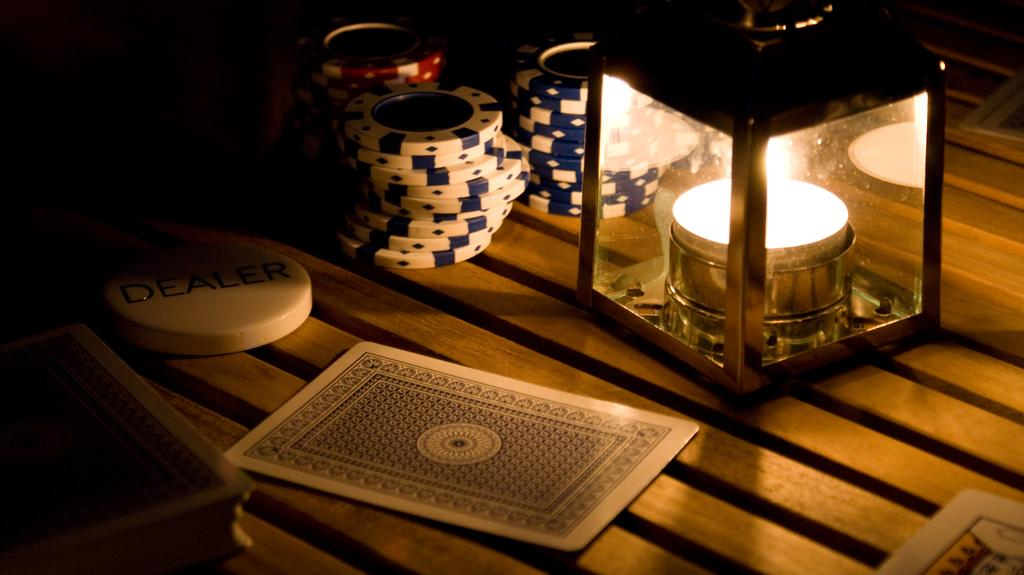What is the main object in the center of the image? There is a table in the center of the image. What items can be seen on the table? Cards and coins are present on the table. What type of light source is on the table? There is a lamp on the table. Where is the banana placed on the table in the image? There is no banana present on the table in the image. How many ducks are visible on the table in the image? There are no ducks present on the table in the image. 